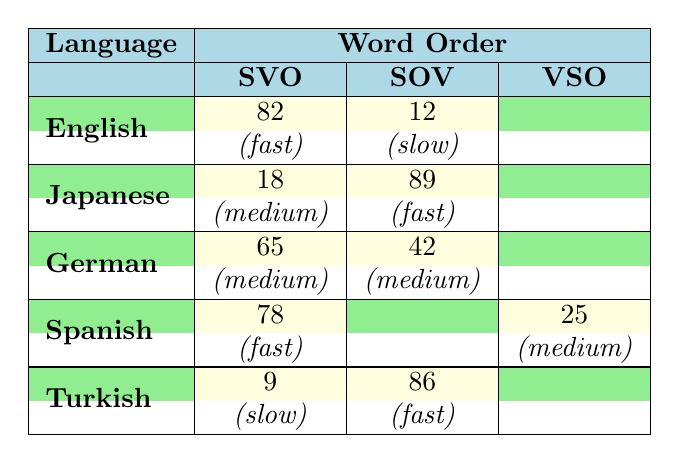What is the processing time for English sentences with SVO word order? The table indicates that for English, the processing time for SVO word order is classified as "fast."
Answer: fast How many languages have a "fast" processing time for SOV word order? Japanese and Turkish show a "fast" processing time for SOV word order, so there are two languages.
Answer: 2 What is the frequency of German sentences with SVO word order compared to those with SOV word order? The frequency of German sentences with SVO word order is 65, while the frequency for SOV is 42. Thus, SVO has a higher frequency by 23 (65 - 42).
Answer: SVO has a frequency of 23 higher than SOV Is there any language that exhibits a slow processing time with SVO word order? Yes, Turkish has a slow processing time associated with its SVO word order.
Answer: Yes What is the total frequency of "fast" processing times across all languages? Summing up the "fast" frequencies: English (82) + Japanese (89) + Spanish (78) + Turkish (86) gives a total of 335.
Answer: 335 How does the frequency of SVO sentences compare between Spanish and English? Spanish has a frequency of 78 for SVO, while English has a frequency of 82, meaning English has a higher frequency by 4 (82 - 78).
Answer: English has a higher frequency by 4 Which language has the highest frequency of "fast" processing times, and what is that frequency? Japanese has the highest frequency of "fast" processing times at 89 for SOV word order.
Answer: Japanese, frequency of 89 If we average the processing times for SVO across all languages, what would that average be considering the given frequencies? The total frequency of SVO is 82 (English) + 18 (Japanese) + 65 (German) + 78 (Spanish) + 9 (Turkish) = 252, and since there are 5 languages, the average is 252/5 = 50.4.
Answer: 50.4 What percentage of Japanese sentences in SOV order have a "fast" processing time? The frequency for Japanese with SOV is 89, which is the only occurrence in this category, so the percentage is 100% (89 out of 89).
Answer: 100% Which word order in Turkish results in a "slow" processing time, and what is its frequency? The table shows that the SVO word order in Turkish has a "slow" processing time with a frequency of 9.
Answer: SVO, frequency of 9 